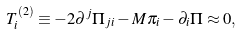Convert formula to latex. <formula><loc_0><loc_0><loc_500><loc_500>T _ { i } ^ { ( 2 ) } \equiv - 2 \partial ^ { j } \Pi _ { j i } - M \pi _ { i } - \partial _ { i } \Pi \approx 0 ,</formula> 